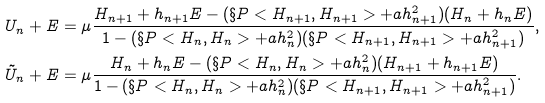Convert formula to latex. <formula><loc_0><loc_0><loc_500><loc_500>U _ { n } + E & = \mu \frac { H _ { n + 1 } + h _ { n + 1 } E - ( \S P < H _ { n + 1 } , H _ { n + 1 } > + a h ^ { 2 } _ { n + 1 } ) ( H _ { n } + h _ { n } E ) } { 1 - ( \S P < H _ { n } , H _ { n } > + a h ^ { 2 } _ { n } ) ( \S P < H _ { n + 1 } , H _ { n + 1 } > + a h ^ { 2 } _ { n + 1 } ) } , \\ \tilde { U } _ { n } + E & = \mu \frac { H _ { n } + h _ { n } E - ( \S P < H _ { n } , H _ { n } > + a h ^ { 2 } _ { n } ) ( H _ { n + 1 } + h _ { n + 1 } E ) } { 1 - ( \S P < H _ { n } , H _ { n } > + a h ^ { 2 } _ { n } ) ( \S P < H _ { n + 1 } , H _ { n + 1 } > + a h ^ { 2 } _ { n + 1 } ) } .</formula> 